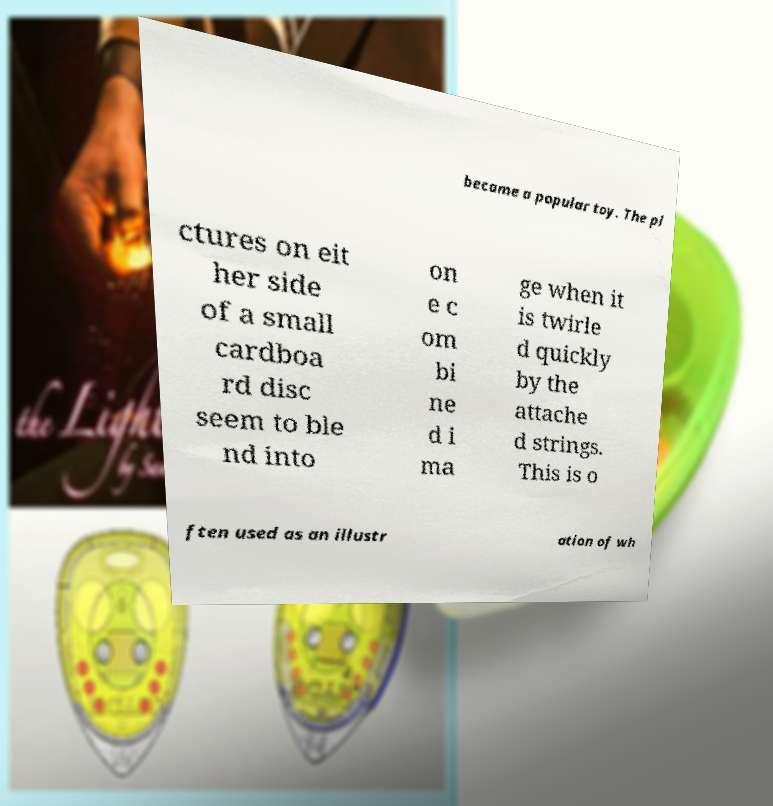For documentation purposes, I need the text within this image transcribed. Could you provide that? became a popular toy. The pi ctures on eit her side of a small cardboa rd disc seem to ble nd into on e c om bi ne d i ma ge when it is twirle d quickly by the attache d strings. This is o ften used as an illustr ation of wh 